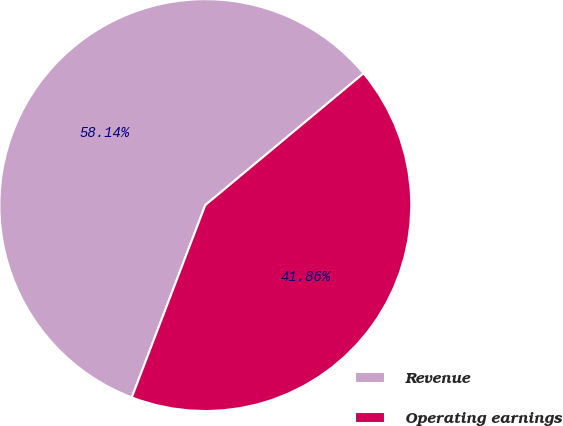Convert chart to OTSL. <chart><loc_0><loc_0><loc_500><loc_500><pie_chart><fcel>Revenue<fcel>Operating earnings<nl><fcel>58.14%<fcel>41.86%<nl></chart> 